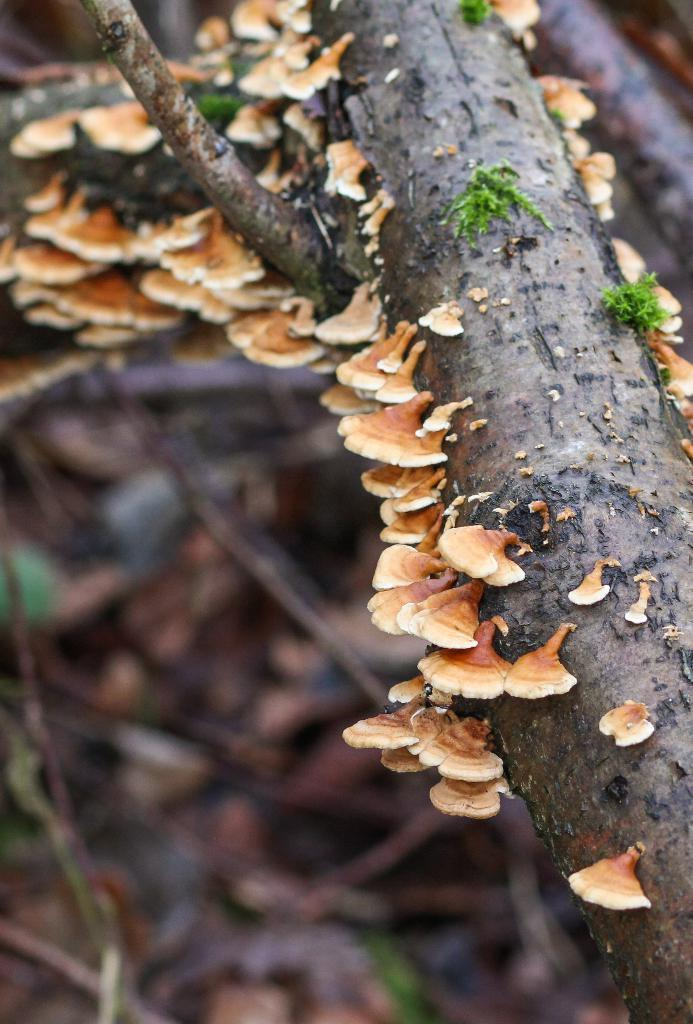What type of fungi can be seen in the image? There are mushrooms on a branch of a tree in the image. Where are the mushrooms located on the tree? The mushrooms are on a branch of the tree. What is the natural habitat of the mushrooms in the image? The mushrooms are growing on a tree branch, which suggests they are in a forest or wooded area. What does the mushroom taste like in the image? The image does not provide any information about the taste of the mushrooms, as it is a visual representation only. 